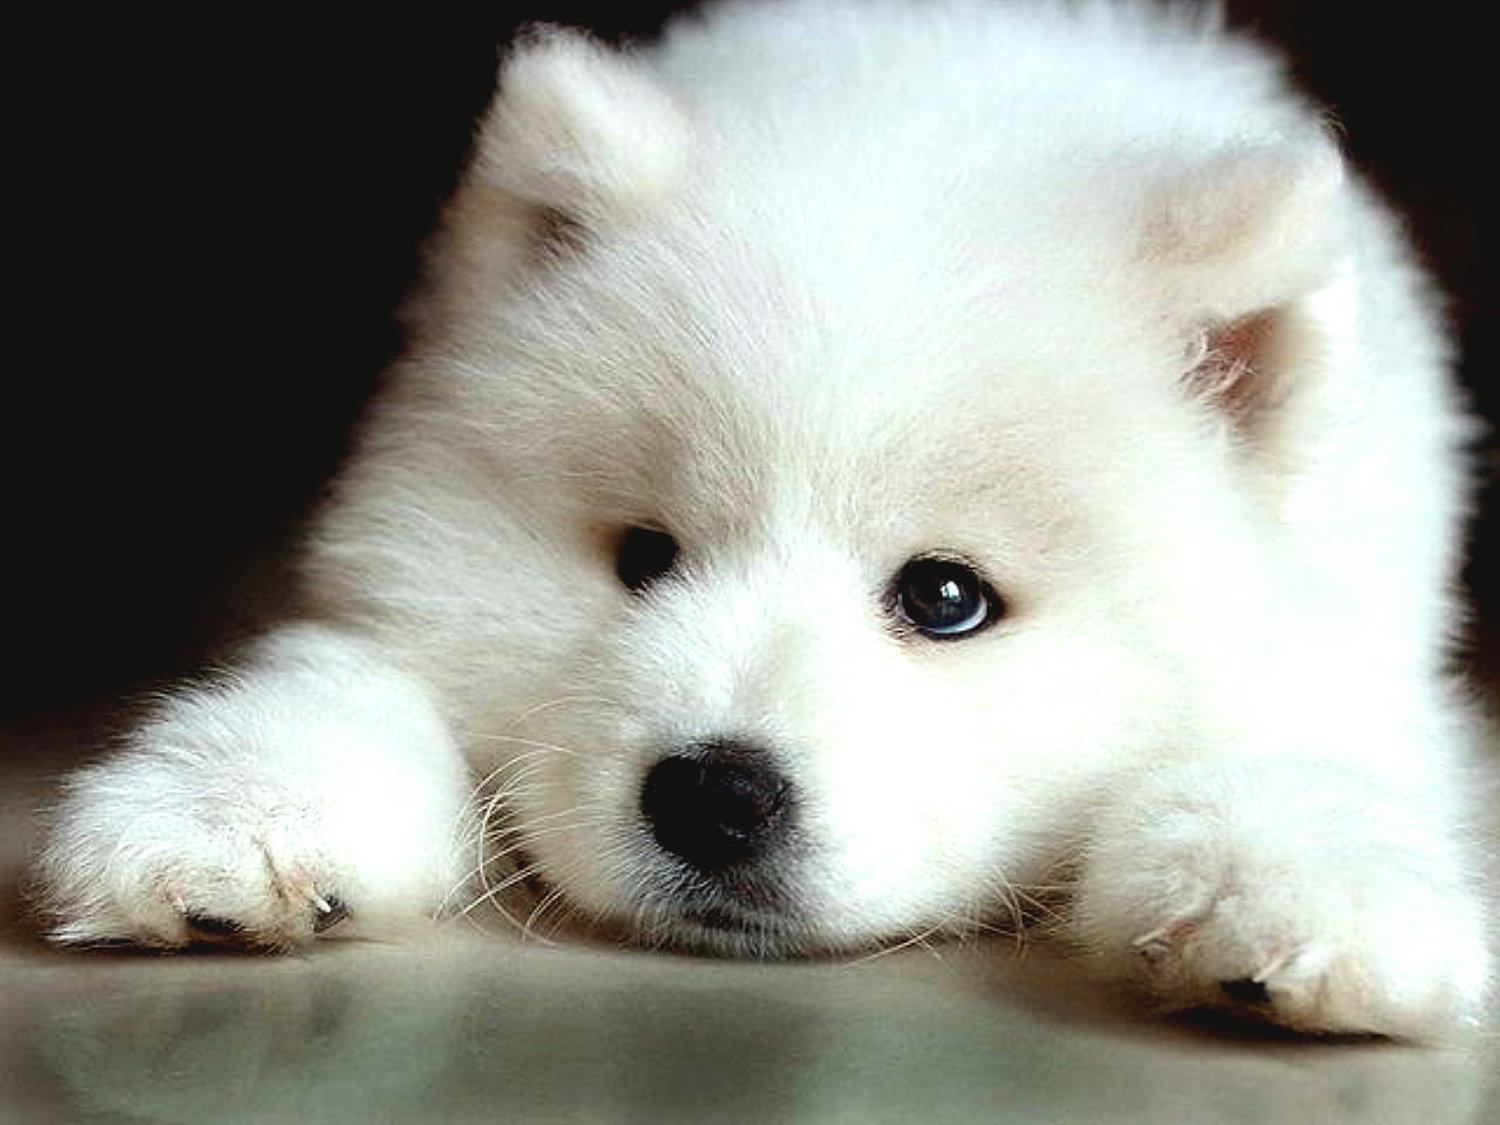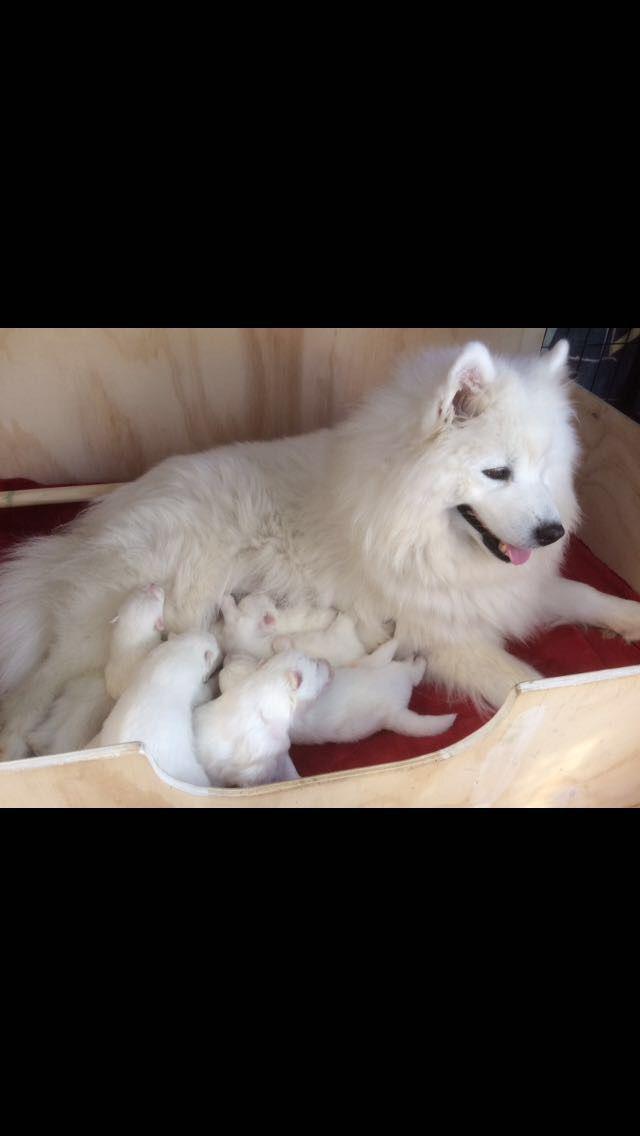The first image is the image on the left, the second image is the image on the right. Analyze the images presented: Is the assertion "In the image to the right, all dogs present are adult;they are mature." valid? Answer yes or no. No. 